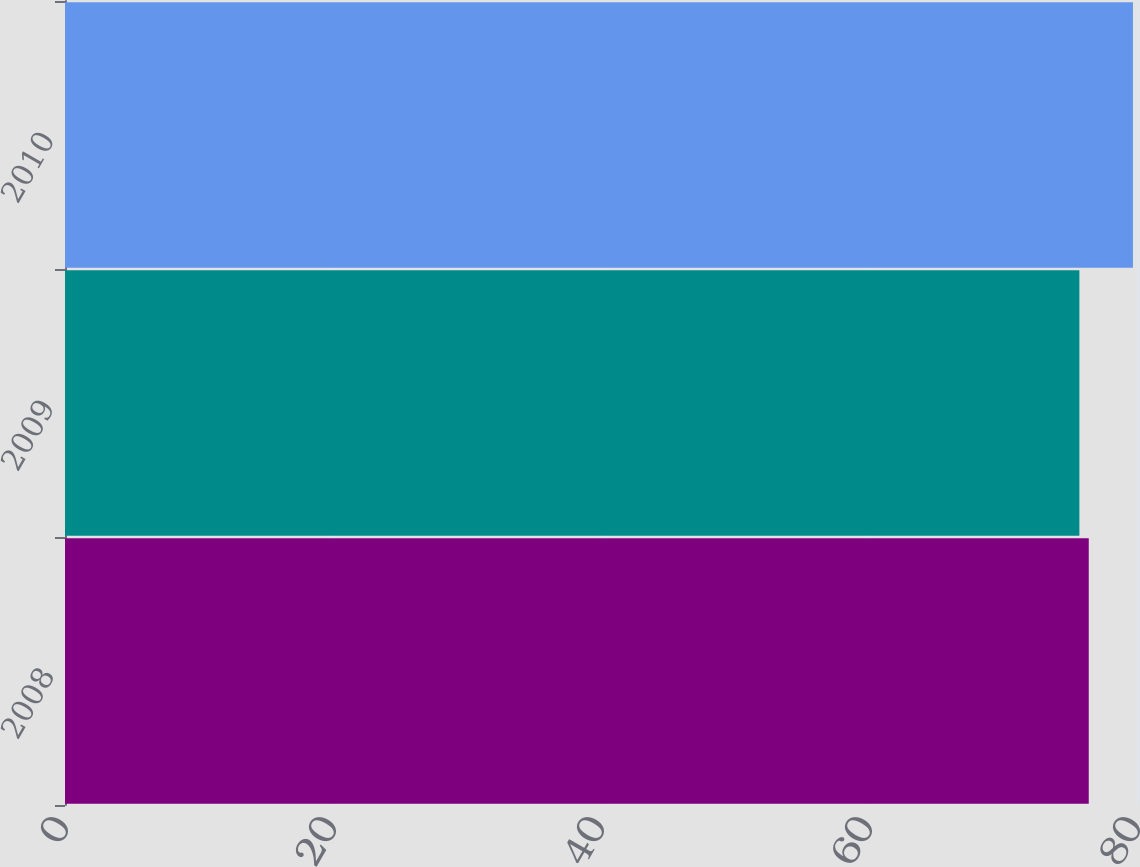Convert chart to OTSL. <chart><loc_0><loc_0><loc_500><loc_500><bar_chart><fcel>2008<fcel>2009<fcel>2010<nl><fcel>76.4<fcel>75.7<fcel>79.7<nl></chart> 